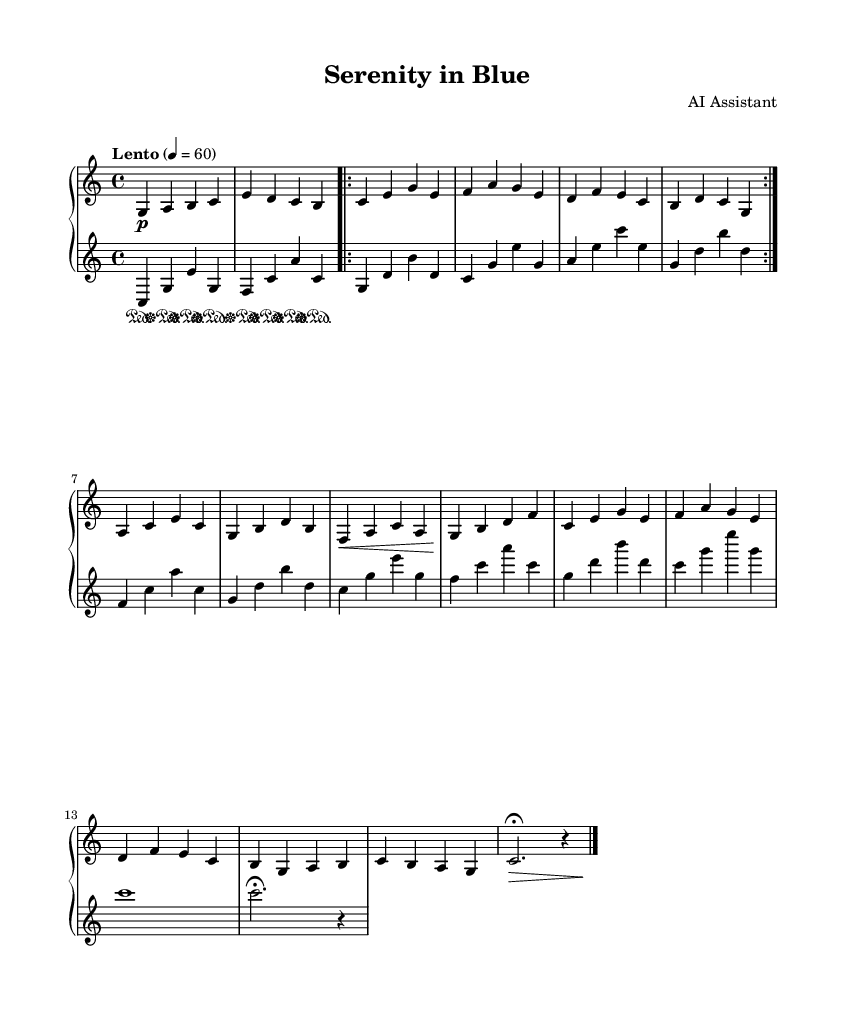What is the key signature of this music? The key signature is C major, which has no sharps or flats noted on the staff.
Answer: C major What is the time signature of this piece? The time signature is indicated as 4/4, meaning there are four beats in each measure.
Answer: 4/4 What is the tempo marking for this piece? The tempo marking is "Lento," which indicates a slow tempo at a speed of 60 beats per minute.
Answer: Lento How many measures are there in the first section (A)? The first section (A) is repeated twice, consisting of 4 measures per repeat, making a total of 8 measures.
Answer: 8 What dynamic markings are used throughout this piece? The dynamic markings include "p" for piano (soft), ">" for a crescendo, and "\fermata" to hold longer.
Answer: p, >, \fermata What is the structure of the piece based on the sections? The structure consists of an Introduction, Section A (repeated), Section B, A' (a variation of A), and an Outro.
Answer: Intro, A, B, A', Outro 